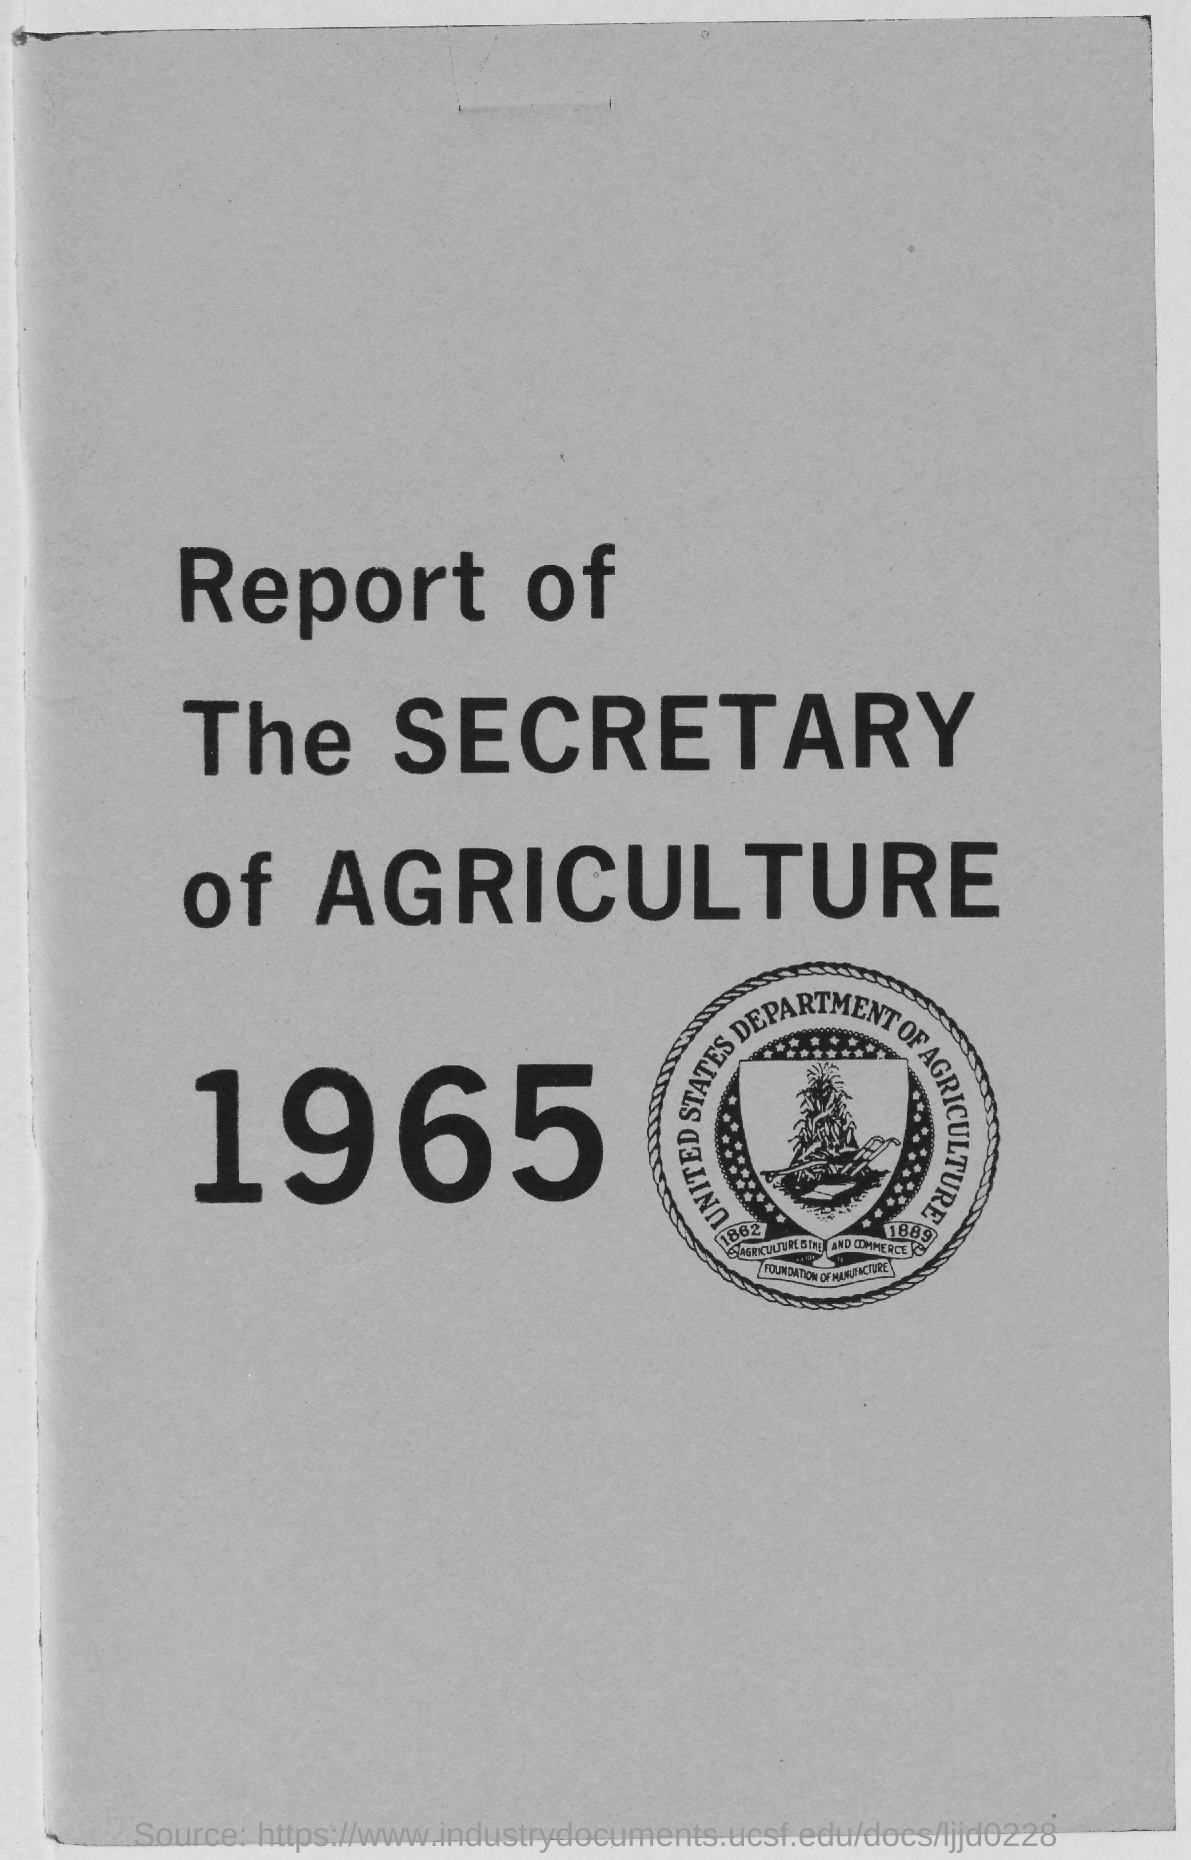What report is given here?
Provide a succinct answer. Report of the Secretary of Agriculture 1965. 